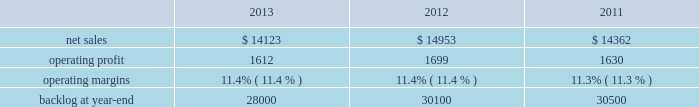Aeronautics our aeronautics business segment is engaged in the research , design , development , manufacture , integration , sustainment , support , and upgrade of advanced military aircraft , including combat and air mobility aircraft , unmanned air vehicles , and related technologies .
Aeronautics 2019 major programs include the f-35 lightning ii joint strike fighter , c-130 hercules , f-16 fighting falcon , f-22 raptor , and the c-5m super galaxy .
Aeronautics 2019 operating results included the following ( in millions ) : .
2013 compared to 2012 aeronautics 2019 net sales for 2013 decreased $ 830 million , or 6% ( 6 % ) , compared to 2012 .
The decrease was primarily attributable to lower net sales of approximately $ 530 million for the f-16 program due to fewer aircraft deliveries ( 13 aircraft delivered in 2013 compared to 37 delivered in 2012 ) partially offset by aircraft configuration mix ; about $ 385 million for the c-130 program due to fewer aircraft deliveries ( 25 aircraft delivered in 2013 compared to 34 in 2012 ) partially offset by increased sustainment activities ; approximately $ 255 million for the f-22 program , which includes about $ 205 million due to decreased production volume as final aircraft deliveries were completed during the second quarter of 2012 and $ 50 million from the favorable resolution of a contractual matter during the second quarter of 2012 ; and about $ 270 million for various other programs ( primarily sustainment activities ) due to decreased volume .
The decreases were partially offset by higher net sales of about $ 295 million for f-35 production contracts due to increased production volume and risk retirements ; approximately $ 245 million for the c-5 program due to increased aircraft deliveries ( six aircraft delivered in 2013 compared to four in 2012 ) and other modernization activities ; and about $ 70 million for the f-35 development contract due to increased volume .
Aeronautics 2019 operating profit for 2013 decreased $ 87 million , or 5% ( 5 % ) , compared to 2012 .
The decrease was primarily attributable to lower operating profit of about $ 85 million for the f-22 program , which includes approximately $ 50 million from the favorable resolution of a contractual matter in the second quarter of 2012 and about $ 35 million due to decreased risk retirements and production volume ; approximately $ 70 million for the c-130 program due to lower risk retirements and fewer deliveries partially offset by increased sustainment activities ; about $ 65 million for the c-5 program due to the inception-to-date effect of reducing the profit booking rate in the third quarter of 2013 and lower risk retirements ; approximately $ 35 million for the f-16 program due to fewer aircraft deliveries partially offset by increased sustainment activity and aircraft configuration mix .
The decreases were partially offset by higher operating profit of approximately $ 180 million for f-35 production contracts due to increased risk retirements and volume .
Operating profit was comparable for the f-35 development contract and included adjustments of approximately $ 85 million to reflect the inception-to-date impacts of the downward revisions to the profit booking rate in both 2013 and 2012 .
Adjustments not related to volume , including net profit booking rate adjustments and other matters , were approximately $ 75 million lower for 2013 compared to 2012 compared to 2011 aeronautics 2019 net sales for 2012 increased $ 591 million , or 4% ( 4 % ) , compared to 2011 .
The increase was attributable to higher net sales of approximately $ 745 million from f-35 production contracts principally due to increased production volume ; about $ 285 million from f-16 programs primarily due to higher aircraft deliveries ( 37 f-16 aircraft delivered in 2012 compared to 22 in 2011 ) partially offset by lower volume on sustainment activities due to the completion of modification programs for certain international customers ; and approximately $ 140 million from c-5 programs due to higher aircraft deliveries ( four c-5m aircraft delivered in 2012 compared to two in 2011 ) .
Partially offsetting the increases were lower net sales of approximately $ 365 million from decreased production volume and lower risk retirements on the f-22 program as final aircraft deliveries were completed in the second quarter of 2012 ; approximately $ 110 million from the f-35 development contract primarily due to the inception-to-date effect of reducing the profit booking rate in the second quarter of 2012 and to a lesser extent lower volume ; and about $ 95 million from a decrease in volume on other sustainment activities partially offset by various other aeronautics programs due to higher volume .
Net sales for c-130 programs were comparable to 2011 as a decline in sustainment activities largely was offset by increased aircraft deliveries. .
What was the average net sales in millions for aeronautics from 2001 to 2013? 
Computations: table_average(operating profit, none)
Answer: 1647.0. 